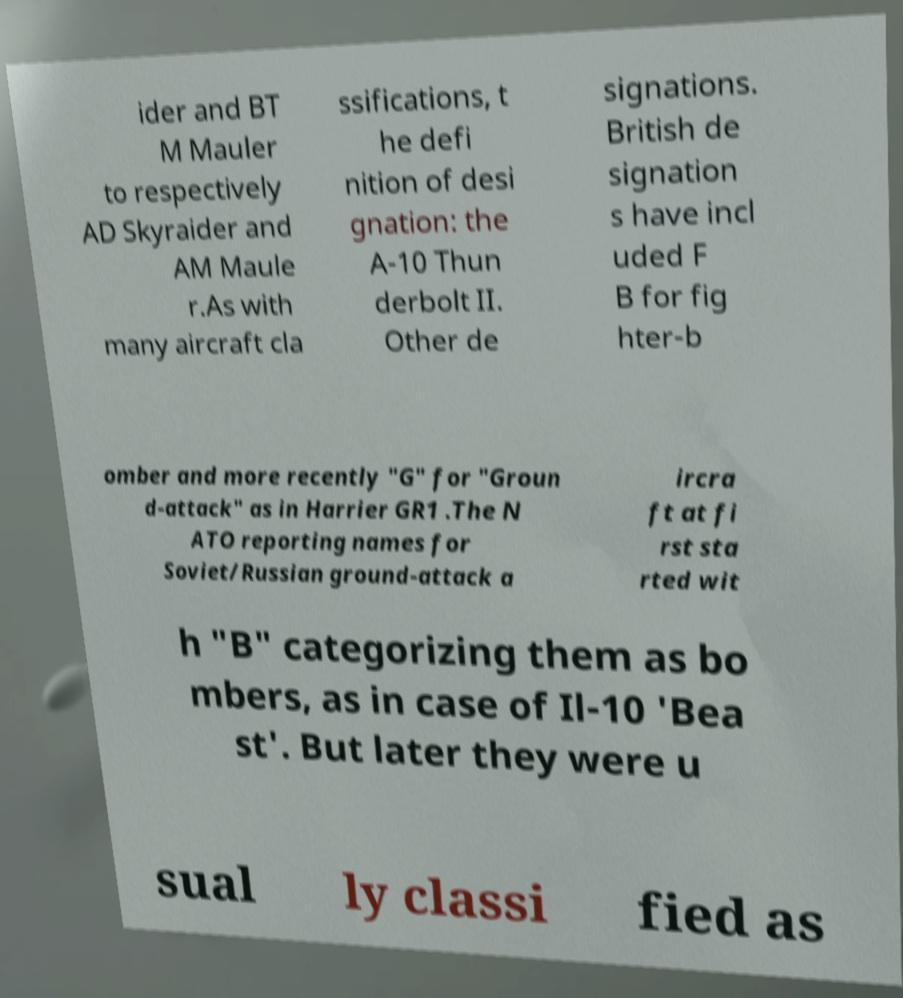Can you accurately transcribe the text from the provided image for me? ider and BT M Mauler to respectively AD Skyraider and AM Maule r.As with many aircraft cla ssifications, t he defi nition of desi gnation: the A-10 Thun derbolt II. Other de signations. British de signation s have incl uded F B for fig hter-b omber and more recently "G" for "Groun d-attack" as in Harrier GR1 .The N ATO reporting names for Soviet/Russian ground-attack a ircra ft at fi rst sta rted wit h "B" categorizing them as bo mbers, as in case of Il-10 'Bea st'. But later they were u sual ly classi fied as 